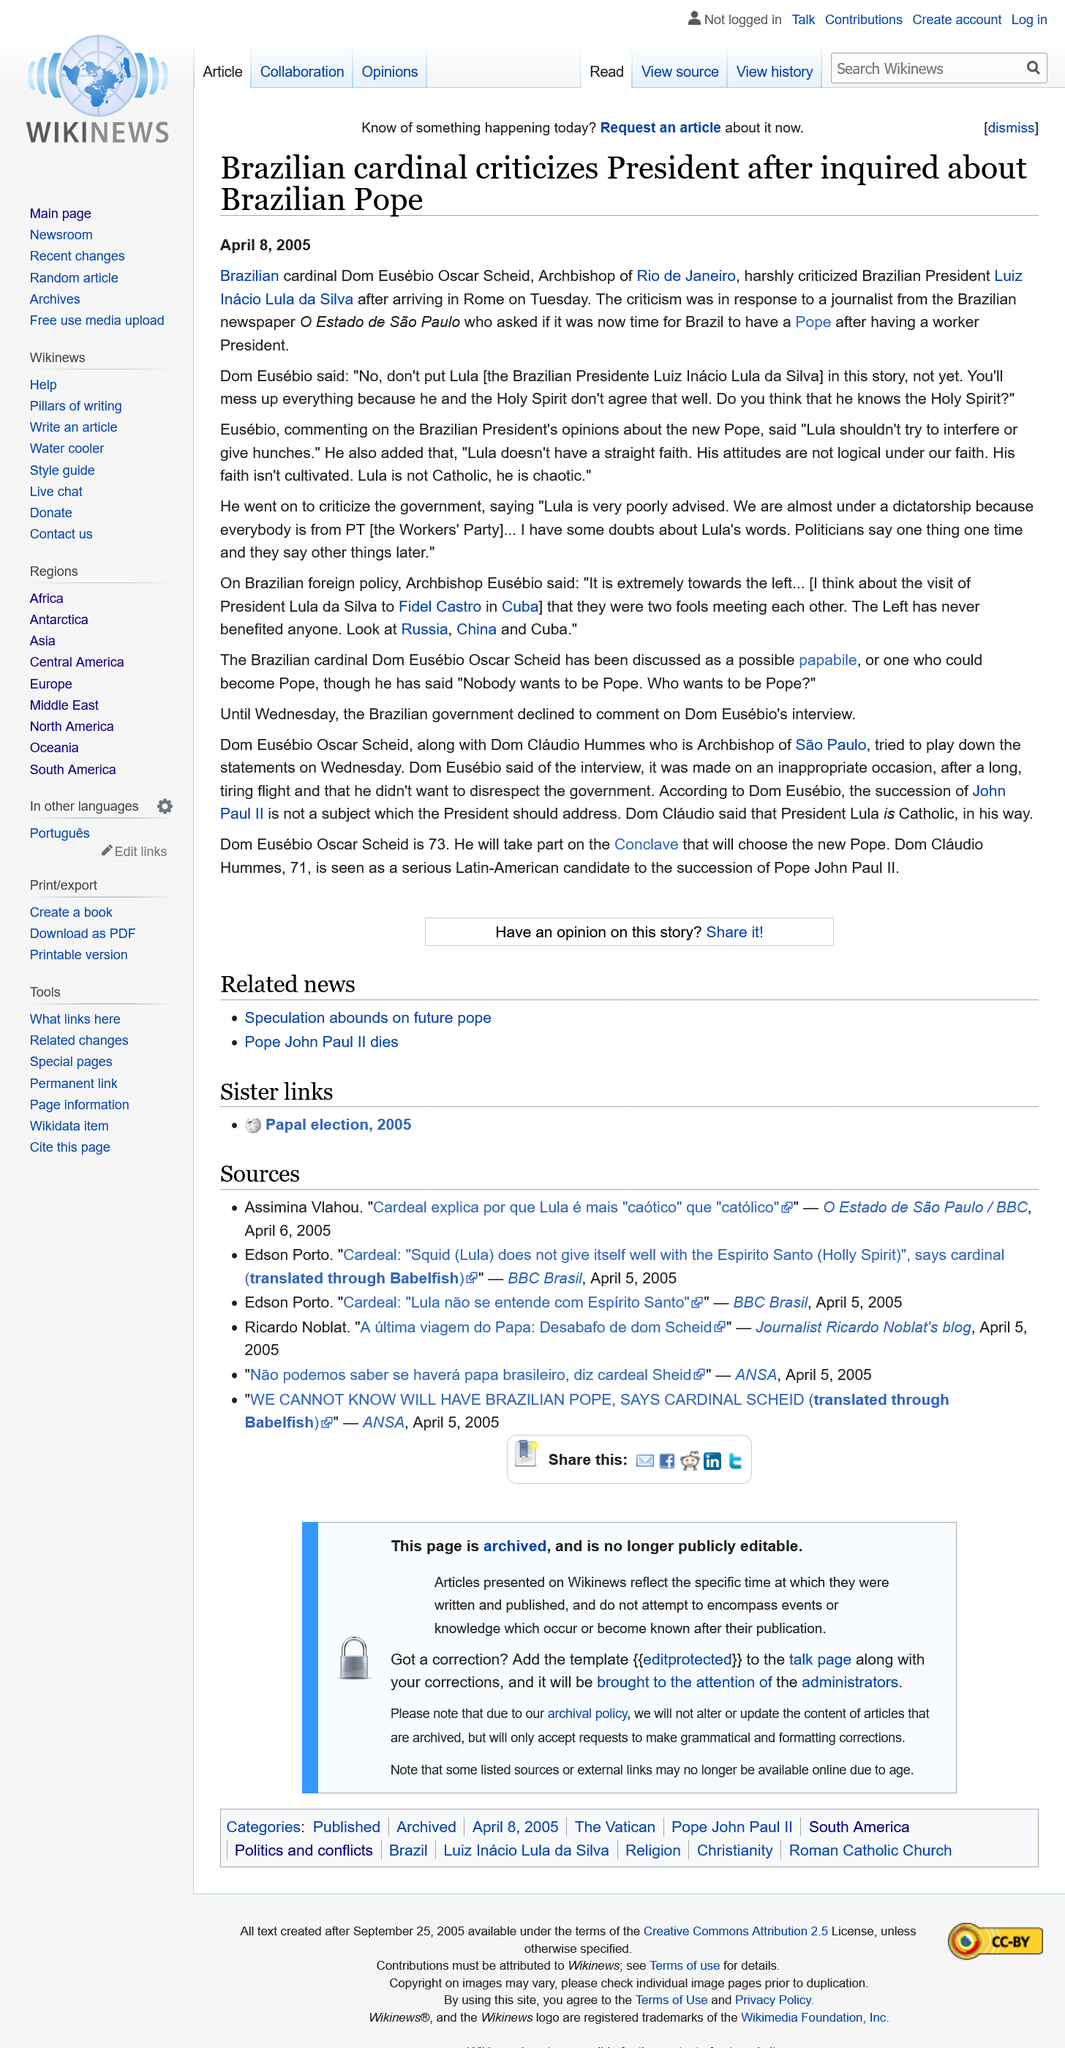Specify some key components in this picture. The question asked by Brazilian cardinal Dom Eusébio was 'Do you think he knows the Holy Spirit?' Dom Eusebio Oscar Scheid, the Archbishop of Rio de Janeiro and a Brazilian cardinal, has criticized the actions of the Brazilian President. The criticism was directed towards a journalist from a Brazilian newspaper who inquired if it was time for Brazil to have a Pope after having a working President. 